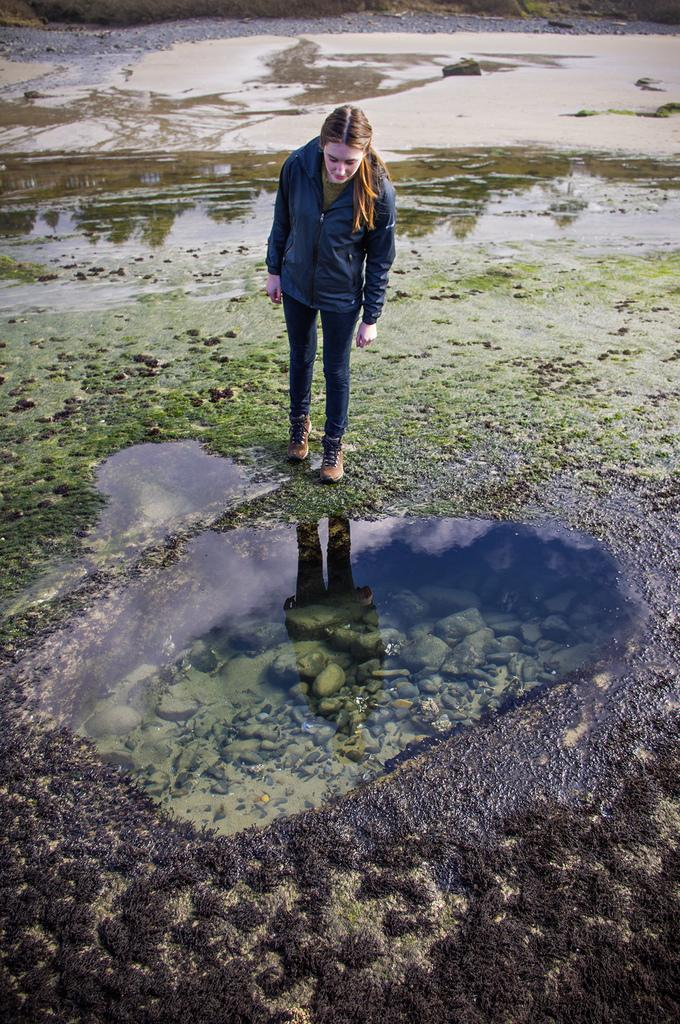Who is present in the image? There is a woman in the image. What is the woman standing on? The woman is standing on a wet surface of grass. What can be seen in the background of the image? There is water visible in the image. What type of dish is the woman cooking in the image? There is no dish or cooking activity present in the image. 